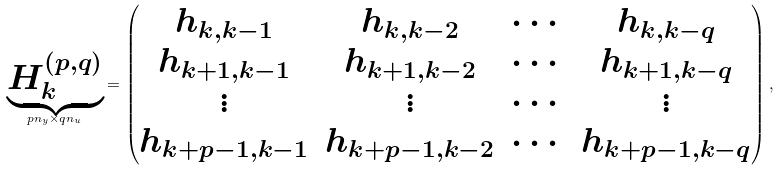Convert formula to latex. <formula><loc_0><loc_0><loc_500><loc_500>\underbrace { H _ { k } ^ { ( p , q ) } } _ { p n _ { y } \times q n _ { u } } = \begin{pmatrix} h _ { k , k - 1 } & h _ { k , k - 2 } & \cdots & h _ { k , k - q } \\ h _ { k + 1 , k - 1 } & h _ { k + 1 , k - 2 } & \cdots & h _ { k + 1 , k - q } \\ \vdots & \vdots & \cdots & \vdots \\ h _ { k + p - 1 , k - 1 } & h _ { k + p - 1 , k - 2 } & \cdots & h _ { k + p - 1 , k - q } \end{pmatrix} ,</formula> 